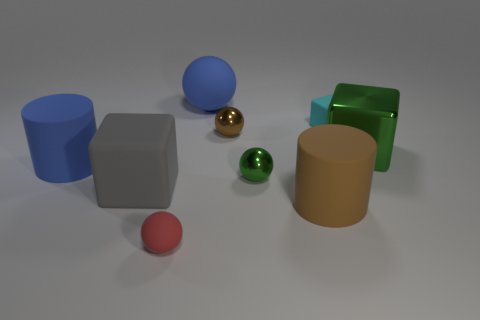Add 1 large green shiny things. How many objects exist? 10 Subtract all cylinders. How many objects are left? 7 Add 5 brown shiny things. How many brown shiny things exist? 6 Subtract 0 purple spheres. How many objects are left? 9 Subtract all large gray cubes. Subtract all big green cubes. How many objects are left? 7 Add 8 green spheres. How many green spheres are left? 9 